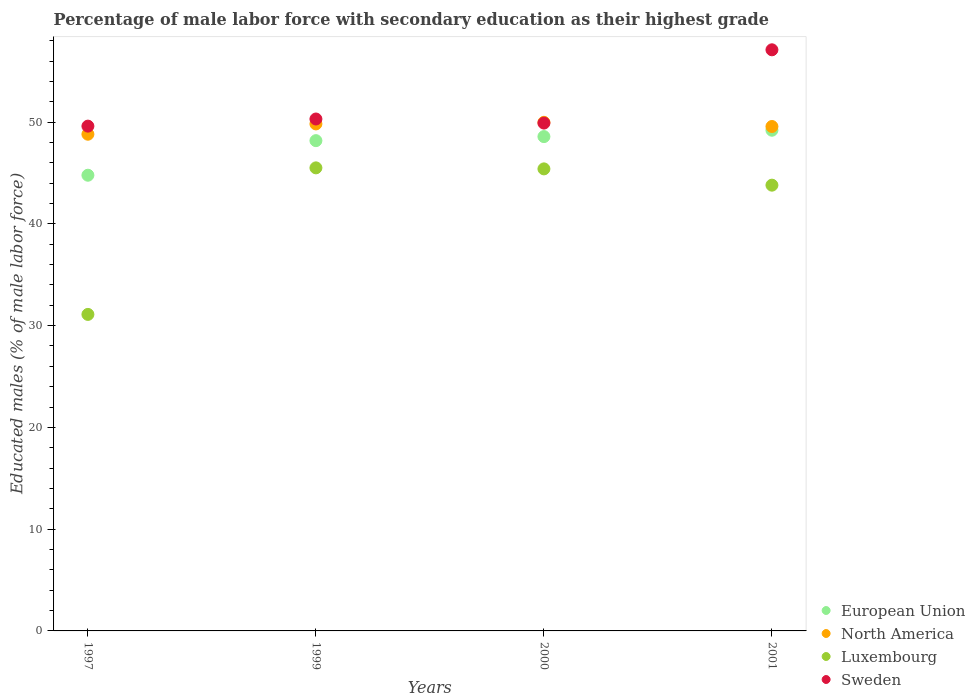How many different coloured dotlines are there?
Keep it short and to the point. 4. What is the percentage of male labor force with secondary education in North America in 2000?
Give a very brief answer. 49.98. Across all years, what is the maximum percentage of male labor force with secondary education in Luxembourg?
Offer a very short reply. 45.5. Across all years, what is the minimum percentage of male labor force with secondary education in Sweden?
Your answer should be compact. 49.6. In which year was the percentage of male labor force with secondary education in North America maximum?
Ensure brevity in your answer.  2000. What is the total percentage of male labor force with secondary education in North America in the graph?
Offer a very short reply. 198.16. What is the difference between the percentage of male labor force with secondary education in North America in 1999 and that in 2001?
Offer a very short reply. 0.25. What is the difference between the percentage of male labor force with secondary education in Sweden in 2001 and the percentage of male labor force with secondary education in North America in 2000?
Ensure brevity in your answer.  7.12. What is the average percentage of male labor force with secondary education in European Union per year?
Provide a short and direct response. 47.68. In the year 1999, what is the difference between the percentage of male labor force with secondary education in North America and percentage of male labor force with secondary education in European Union?
Give a very brief answer. 1.64. In how many years, is the percentage of male labor force with secondary education in Sweden greater than 50 %?
Make the answer very short. 2. What is the ratio of the percentage of male labor force with secondary education in European Union in 2000 to that in 2001?
Your response must be concise. 0.99. Is the difference between the percentage of male labor force with secondary education in North America in 2000 and 2001 greater than the difference between the percentage of male labor force with secondary education in European Union in 2000 and 2001?
Your answer should be compact. Yes. What is the difference between the highest and the second highest percentage of male labor force with secondary education in Sweden?
Your answer should be very brief. 6.8. What is the difference between the highest and the lowest percentage of male labor force with secondary education in Luxembourg?
Your answer should be compact. 14.4. Are the values on the major ticks of Y-axis written in scientific E-notation?
Make the answer very short. No. Does the graph contain any zero values?
Keep it short and to the point. No. How many legend labels are there?
Make the answer very short. 4. What is the title of the graph?
Provide a short and direct response. Percentage of male labor force with secondary education as their highest grade. Does "Grenada" appear as one of the legend labels in the graph?
Make the answer very short. No. What is the label or title of the X-axis?
Provide a short and direct response. Years. What is the label or title of the Y-axis?
Your response must be concise. Educated males (% of male labor force). What is the Educated males (% of male labor force) in European Union in 1997?
Offer a very short reply. 44.78. What is the Educated males (% of male labor force) of North America in 1997?
Your answer should be compact. 48.81. What is the Educated males (% of male labor force) of Luxembourg in 1997?
Give a very brief answer. 31.1. What is the Educated males (% of male labor force) of Sweden in 1997?
Provide a succinct answer. 49.6. What is the Educated males (% of male labor force) of European Union in 1999?
Provide a succinct answer. 48.17. What is the Educated males (% of male labor force) in North America in 1999?
Ensure brevity in your answer.  49.82. What is the Educated males (% of male labor force) in Luxembourg in 1999?
Offer a terse response. 45.5. What is the Educated males (% of male labor force) of Sweden in 1999?
Keep it short and to the point. 50.3. What is the Educated males (% of male labor force) of European Union in 2000?
Keep it short and to the point. 48.57. What is the Educated males (% of male labor force) in North America in 2000?
Ensure brevity in your answer.  49.98. What is the Educated males (% of male labor force) of Luxembourg in 2000?
Your answer should be compact. 45.4. What is the Educated males (% of male labor force) in Sweden in 2000?
Your response must be concise. 49.9. What is the Educated males (% of male labor force) in European Union in 2001?
Provide a succinct answer. 49.2. What is the Educated males (% of male labor force) of North America in 2001?
Provide a short and direct response. 49.56. What is the Educated males (% of male labor force) of Luxembourg in 2001?
Your answer should be very brief. 43.8. What is the Educated males (% of male labor force) of Sweden in 2001?
Provide a succinct answer. 57.1. Across all years, what is the maximum Educated males (% of male labor force) in European Union?
Make the answer very short. 49.2. Across all years, what is the maximum Educated males (% of male labor force) in North America?
Provide a succinct answer. 49.98. Across all years, what is the maximum Educated males (% of male labor force) in Luxembourg?
Your answer should be very brief. 45.5. Across all years, what is the maximum Educated males (% of male labor force) of Sweden?
Your answer should be very brief. 57.1. Across all years, what is the minimum Educated males (% of male labor force) of European Union?
Make the answer very short. 44.78. Across all years, what is the minimum Educated males (% of male labor force) in North America?
Ensure brevity in your answer.  48.81. Across all years, what is the minimum Educated males (% of male labor force) of Luxembourg?
Keep it short and to the point. 31.1. Across all years, what is the minimum Educated males (% of male labor force) in Sweden?
Give a very brief answer. 49.6. What is the total Educated males (% of male labor force) of European Union in the graph?
Make the answer very short. 190.72. What is the total Educated males (% of male labor force) in North America in the graph?
Provide a short and direct response. 198.16. What is the total Educated males (% of male labor force) in Luxembourg in the graph?
Ensure brevity in your answer.  165.8. What is the total Educated males (% of male labor force) in Sweden in the graph?
Your answer should be compact. 206.9. What is the difference between the Educated males (% of male labor force) of European Union in 1997 and that in 1999?
Ensure brevity in your answer.  -3.4. What is the difference between the Educated males (% of male labor force) of North America in 1997 and that in 1999?
Your answer should be very brief. -1.01. What is the difference between the Educated males (% of male labor force) in Luxembourg in 1997 and that in 1999?
Your answer should be compact. -14.4. What is the difference between the Educated males (% of male labor force) in Sweden in 1997 and that in 1999?
Provide a succinct answer. -0.7. What is the difference between the Educated males (% of male labor force) of European Union in 1997 and that in 2000?
Offer a very short reply. -3.8. What is the difference between the Educated males (% of male labor force) of North America in 1997 and that in 2000?
Keep it short and to the point. -1.17. What is the difference between the Educated males (% of male labor force) of Luxembourg in 1997 and that in 2000?
Your answer should be very brief. -14.3. What is the difference between the Educated males (% of male labor force) in Sweden in 1997 and that in 2000?
Provide a succinct answer. -0.3. What is the difference between the Educated males (% of male labor force) in European Union in 1997 and that in 2001?
Offer a very short reply. -4.42. What is the difference between the Educated males (% of male labor force) in North America in 1997 and that in 2001?
Your answer should be compact. -0.76. What is the difference between the Educated males (% of male labor force) of Sweden in 1997 and that in 2001?
Provide a succinct answer. -7.5. What is the difference between the Educated males (% of male labor force) of European Union in 1999 and that in 2000?
Provide a succinct answer. -0.4. What is the difference between the Educated males (% of male labor force) in North America in 1999 and that in 2000?
Offer a very short reply. -0.16. What is the difference between the Educated males (% of male labor force) of European Union in 1999 and that in 2001?
Your answer should be very brief. -1.02. What is the difference between the Educated males (% of male labor force) of North America in 1999 and that in 2001?
Your answer should be very brief. 0.25. What is the difference between the Educated males (% of male labor force) of Luxembourg in 1999 and that in 2001?
Give a very brief answer. 1.7. What is the difference between the Educated males (% of male labor force) of Sweden in 1999 and that in 2001?
Keep it short and to the point. -6.8. What is the difference between the Educated males (% of male labor force) in European Union in 2000 and that in 2001?
Your answer should be very brief. -0.63. What is the difference between the Educated males (% of male labor force) in North America in 2000 and that in 2001?
Your response must be concise. 0.41. What is the difference between the Educated males (% of male labor force) in European Union in 1997 and the Educated males (% of male labor force) in North America in 1999?
Offer a terse response. -5.04. What is the difference between the Educated males (% of male labor force) in European Union in 1997 and the Educated males (% of male labor force) in Luxembourg in 1999?
Make the answer very short. -0.72. What is the difference between the Educated males (% of male labor force) of European Union in 1997 and the Educated males (% of male labor force) of Sweden in 1999?
Your response must be concise. -5.52. What is the difference between the Educated males (% of male labor force) of North America in 1997 and the Educated males (% of male labor force) of Luxembourg in 1999?
Your answer should be very brief. 3.31. What is the difference between the Educated males (% of male labor force) in North America in 1997 and the Educated males (% of male labor force) in Sweden in 1999?
Make the answer very short. -1.49. What is the difference between the Educated males (% of male labor force) of Luxembourg in 1997 and the Educated males (% of male labor force) of Sweden in 1999?
Keep it short and to the point. -19.2. What is the difference between the Educated males (% of male labor force) of European Union in 1997 and the Educated males (% of male labor force) of North America in 2000?
Offer a very short reply. -5.2. What is the difference between the Educated males (% of male labor force) in European Union in 1997 and the Educated males (% of male labor force) in Luxembourg in 2000?
Your response must be concise. -0.62. What is the difference between the Educated males (% of male labor force) of European Union in 1997 and the Educated males (% of male labor force) of Sweden in 2000?
Offer a very short reply. -5.12. What is the difference between the Educated males (% of male labor force) in North America in 1997 and the Educated males (% of male labor force) in Luxembourg in 2000?
Your answer should be compact. 3.41. What is the difference between the Educated males (% of male labor force) of North America in 1997 and the Educated males (% of male labor force) of Sweden in 2000?
Provide a succinct answer. -1.09. What is the difference between the Educated males (% of male labor force) of Luxembourg in 1997 and the Educated males (% of male labor force) of Sweden in 2000?
Make the answer very short. -18.8. What is the difference between the Educated males (% of male labor force) of European Union in 1997 and the Educated males (% of male labor force) of North America in 2001?
Provide a succinct answer. -4.79. What is the difference between the Educated males (% of male labor force) of European Union in 1997 and the Educated males (% of male labor force) of Luxembourg in 2001?
Make the answer very short. 0.98. What is the difference between the Educated males (% of male labor force) in European Union in 1997 and the Educated males (% of male labor force) in Sweden in 2001?
Your answer should be very brief. -12.32. What is the difference between the Educated males (% of male labor force) in North America in 1997 and the Educated males (% of male labor force) in Luxembourg in 2001?
Offer a terse response. 5.01. What is the difference between the Educated males (% of male labor force) of North America in 1997 and the Educated males (% of male labor force) of Sweden in 2001?
Make the answer very short. -8.29. What is the difference between the Educated males (% of male labor force) in European Union in 1999 and the Educated males (% of male labor force) in North America in 2000?
Your answer should be compact. -1.8. What is the difference between the Educated males (% of male labor force) in European Union in 1999 and the Educated males (% of male labor force) in Luxembourg in 2000?
Keep it short and to the point. 2.77. What is the difference between the Educated males (% of male labor force) in European Union in 1999 and the Educated males (% of male labor force) in Sweden in 2000?
Give a very brief answer. -1.73. What is the difference between the Educated males (% of male labor force) in North America in 1999 and the Educated males (% of male labor force) in Luxembourg in 2000?
Keep it short and to the point. 4.42. What is the difference between the Educated males (% of male labor force) in North America in 1999 and the Educated males (% of male labor force) in Sweden in 2000?
Provide a succinct answer. -0.08. What is the difference between the Educated males (% of male labor force) in Luxembourg in 1999 and the Educated males (% of male labor force) in Sweden in 2000?
Provide a short and direct response. -4.4. What is the difference between the Educated males (% of male labor force) of European Union in 1999 and the Educated males (% of male labor force) of North America in 2001?
Provide a short and direct response. -1.39. What is the difference between the Educated males (% of male labor force) in European Union in 1999 and the Educated males (% of male labor force) in Luxembourg in 2001?
Keep it short and to the point. 4.37. What is the difference between the Educated males (% of male labor force) in European Union in 1999 and the Educated males (% of male labor force) in Sweden in 2001?
Provide a succinct answer. -8.93. What is the difference between the Educated males (% of male labor force) of North America in 1999 and the Educated males (% of male labor force) of Luxembourg in 2001?
Give a very brief answer. 6.02. What is the difference between the Educated males (% of male labor force) in North America in 1999 and the Educated males (% of male labor force) in Sweden in 2001?
Give a very brief answer. -7.28. What is the difference between the Educated males (% of male labor force) in European Union in 2000 and the Educated males (% of male labor force) in North America in 2001?
Provide a short and direct response. -0.99. What is the difference between the Educated males (% of male labor force) of European Union in 2000 and the Educated males (% of male labor force) of Luxembourg in 2001?
Give a very brief answer. 4.77. What is the difference between the Educated males (% of male labor force) of European Union in 2000 and the Educated males (% of male labor force) of Sweden in 2001?
Make the answer very short. -8.53. What is the difference between the Educated males (% of male labor force) of North America in 2000 and the Educated males (% of male labor force) of Luxembourg in 2001?
Offer a terse response. 6.18. What is the difference between the Educated males (% of male labor force) of North America in 2000 and the Educated males (% of male labor force) of Sweden in 2001?
Ensure brevity in your answer.  -7.12. What is the average Educated males (% of male labor force) of European Union per year?
Ensure brevity in your answer.  47.68. What is the average Educated males (% of male labor force) in North America per year?
Your answer should be compact. 49.54. What is the average Educated males (% of male labor force) in Luxembourg per year?
Ensure brevity in your answer.  41.45. What is the average Educated males (% of male labor force) of Sweden per year?
Keep it short and to the point. 51.73. In the year 1997, what is the difference between the Educated males (% of male labor force) in European Union and Educated males (% of male labor force) in North America?
Your answer should be very brief. -4.03. In the year 1997, what is the difference between the Educated males (% of male labor force) in European Union and Educated males (% of male labor force) in Luxembourg?
Keep it short and to the point. 13.68. In the year 1997, what is the difference between the Educated males (% of male labor force) of European Union and Educated males (% of male labor force) of Sweden?
Offer a very short reply. -4.82. In the year 1997, what is the difference between the Educated males (% of male labor force) in North America and Educated males (% of male labor force) in Luxembourg?
Offer a terse response. 17.71. In the year 1997, what is the difference between the Educated males (% of male labor force) of North America and Educated males (% of male labor force) of Sweden?
Offer a terse response. -0.79. In the year 1997, what is the difference between the Educated males (% of male labor force) in Luxembourg and Educated males (% of male labor force) in Sweden?
Give a very brief answer. -18.5. In the year 1999, what is the difference between the Educated males (% of male labor force) in European Union and Educated males (% of male labor force) in North America?
Your answer should be compact. -1.64. In the year 1999, what is the difference between the Educated males (% of male labor force) of European Union and Educated males (% of male labor force) of Luxembourg?
Offer a very short reply. 2.67. In the year 1999, what is the difference between the Educated males (% of male labor force) of European Union and Educated males (% of male labor force) of Sweden?
Keep it short and to the point. -2.13. In the year 1999, what is the difference between the Educated males (% of male labor force) of North America and Educated males (% of male labor force) of Luxembourg?
Your answer should be compact. 4.32. In the year 1999, what is the difference between the Educated males (% of male labor force) of North America and Educated males (% of male labor force) of Sweden?
Give a very brief answer. -0.48. In the year 2000, what is the difference between the Educated males (% of male labor force) in European Union and Educated males (% of male labor force) in North America?
Offer a terse response. -1.4. In the year 2000, what is the difference between the Educated males (% of male labor force) of European Union and Educated males (% of male labor force) of Luxembourg?
Your response must be concise. 3.17. In the year 2000, what is the difference between the Educated males (% of male labor force) of European Union and Educated males (% of male labor force) of Sweden?
Ensure brevity in your answer.  -1.33. In the year 2000, what is the difference between the Educated males (% of male labor force) of North America and Educated males (% of male labor force) of Luxembourg?
Give a very brief answer. 4.58. In the year 2000, what is the difference between the Educated males (% of male labor force) in North America and Educated males (% of male labor force) in Sweden?
Provide a short and direct response. 0.08. In the year 2000, what is the difference between the Educated males (% of male labor force) in Luxembourg and Educated males (% of male labor force) in Sweden?
Offer a very short reply. -4.5. In the year 2001, what is the difference between the Educated males (% of male labor force) in European Union and Educated males (% of male labor force) in North America?
Give a very brief answer. -0.37. In the year 2001, what is the difference between the Educated males (% of male labor force) in European Union and Educated males (% of male labor force) in Luxembourg?
Make the answer very short. 5.4. In the year 2001, what is the difference between the Educated males (% of male labor force) of European Union and Educated males (% of male labor force) of Sweden?
Your answer should be compact. -7.9. In the year 2001, what is the difference between the Educated males (% of male labor force) in North America and Educated males (% of male labor force) in Luxembourg?
Your response must be concise. 5.76. In the year 2001, what is the difference between the Educated males (% of male labor force) in North America and Educated males (% of male labor force) in Sweden?
Offer a very short reply. -7.54. What is the ratio of the Educated males (% of male labor force) of European Union in 1997 to that in 1999?
Offer a very short reply. 0.93. What is the ratio of the Educated males (% of male labor force) in North America in 1997 to that in 1999?
Your answer should be very brief. 0.98. What is the ratio of the Educated males (% of male labor force) in Luxembourg in 1997 to that in 1999?
Offer a terse response. 0.68. What is the ratio of the Educated males (% of male labor force) in Sweden in 1997 to that in 1999?
Make the answer very short. 0.99. What is the ratio of the Educated males (% of male labor force) in European Union in 1997 to that in 2000?
Ensure brevity in your answer.  0.92. What is the ratio of the Educated males (% of male labor force) in North America in 1997 to that in 2000?
Provide a succinct answer. 0.98. What is the ratio of the Educated males (% of male labor force) of Luxembourg in 1997 to that in 2000?
Keep it short and to the point. 0.69. What is the ratio of the Educated males (% of male labor force) of European Union in 1997 to that in 2001?
Provide a short and direct response. 0.91. What is the ratio of the Educated males (% of male labor force) in North America in 1997 to that in 2001?
Provide a short and direct response. 0.98. What is the ratio of the Educated males (% of male labor force) in Luxembourg in 1997 to that in 2001?
Offer a terse response. 0.71. What is the ratio of the Educated males (% of male labor force) of Sweden in 1997 to that in 2001?
Ensure brevity in your answer.  0.87. What is the ratio of the Educated males (% of male labor force) of Luxembourg in 1999 to that in 2000?
Ensure brevity in your answer.  1. What is the ratio of the Educated males (% of male labor force) of Sweden in 1999 to that in 2000?
Give a very brief answer. 1.01. What is the ratio of the Educated males (% of male labor force) of European Union in 1999 to that in 2001?
Make the answer very short. 0.98. What is the ratio of the Educated males (% of male labor force) in Luxembourg in 1999 to that in 2001?
Give a very brief answer. 1.04. What is the ratio of the Educated males (% of male labor force) in Sweden in 1999 to that in 2001?
Ensure brevity in your answer.  0.88. What is the ratio of the Educated males (% of male labor force) in European Union in 2000 to that in 2001?
Your response must be concise. 0.99. What is the ratio of the Educated males (% of male labor force) in North America in 2000 to that in 2001?
Your answer should be compact. 1.01. What is the ratio of the Educated males (% of male labor force) of Luxembourg in 2000 to that in 2001?
Give a very brief answer. 1.04. What is the ratio of the Educated males (% of male labor force) of Sweden in 2000 to that in 2001?
Ensure brevity in your answer.  0.87. What is the difference between the highest and the second highest Educated males (% of male labor force) in European Union?
Give a very brief answer. 0.63. What is the difference between the highest and the second highest Educated males (% of male labor force) of North America?
Provide a succinct answer. 0.16. What is the difference between the highest and the lowest Educated males (% of male labor force) of European Union?
Give a very brief answer. 4.42. What is the difference between the highest and the lowest Educated males (% of male labor force) of North America?
Provide a short and direct response. 1.17. 